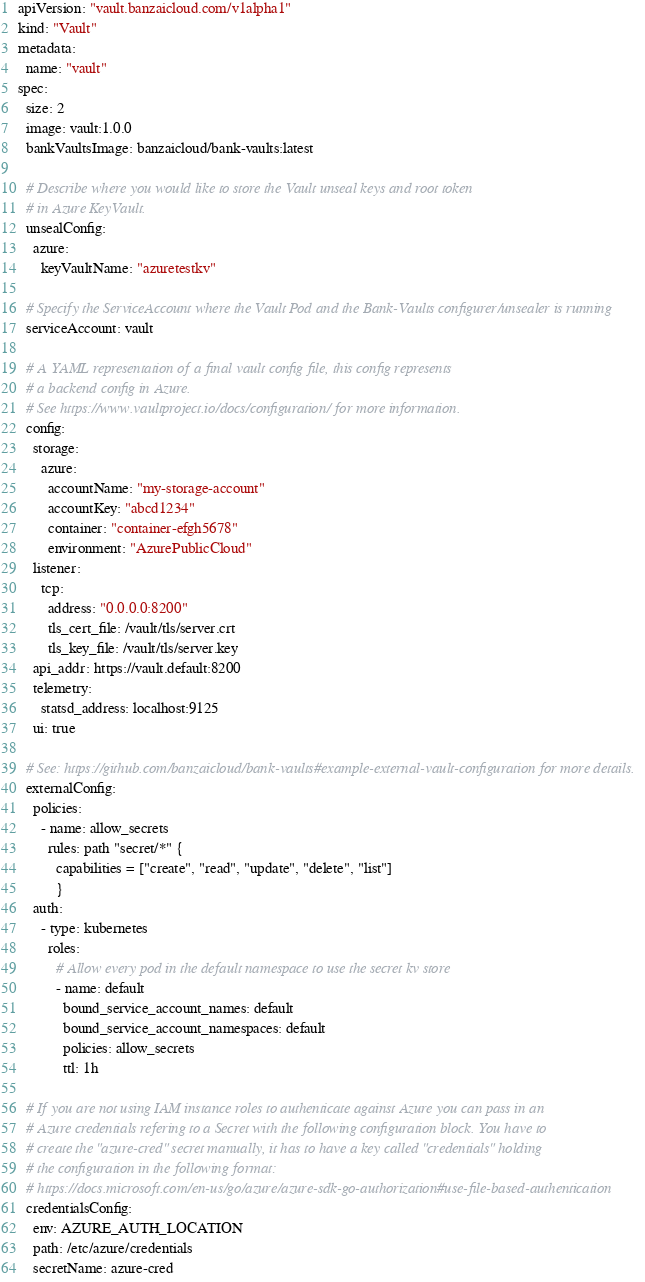<code> <loc_0><loc_0><loc_500><loc_500><_YAML_>apiVersion: "vault.banzaicloud.com/v1alpha1"
kind: "Vault"
metadata:
  name: "vault"
spec:
  size: 2
  image: vault:1.0.0
  bankVaultsImage: banzaicloud/bank-vaults:latest

  # Describe where you would like to store the Vault unseal keys and root token
  # in Azure KeyVault.
  unsealConfig:
    azure:
      keyVaultName: "azuretestkv"

  # Specify the ServiceAccount where the Vault Pod and the Bank-Vaults configurer/unsealer is running
  serviceAccount: vault

  # A YAML representation of a final vault config file, this config represents
  # a backend config in Azure.
  # See https://www.vaultproject.io/docs/configuration/ for more information.
  config:
    storage:
      azure:
        accountName: "my-storage-account"
        accountKey: "abcd1234"
        container: "container-efgh5678"
        environment: "AzurePublicCloud"
    listener:
      tcp:
        address: "0.0.0.0:8200"
        tls_cert_file: /vault/tls/server.crt
        tls_key_file: /vault/tls/server.key
    api_addr: https://vault.default:8200
    telemetry:
      statsd_address: localhost:9125
    ui: true

  # See: https://github.com/banzaicloud/bank-vaults#example-external-vault-configuration for more details.
  externalConfig:
    policies:
      - name: allow_secrets
        rules: path "secret/*" {
          capabilities = ["create", "read", "update", "delete", "list"]
          }
    auth:
      - type: kubernetes
        roles:
          # Allow every pod in the default namespace to use the secret kv store
          - name: default
            bound_service_account_names: default
            bound_service_account_namespaces: default
            policies: allow_secrets
            ttl: 1h

  # If you are not using IAM instance roles to authenticate against Azure you can pass in an
  # Azure credentials refering to a Secret with the following configuration block. You have to
  # create the "azure-cred" secret manually, it has to have a key called "credentials" holding
  # the configuration in the following format:
  # https://docs.microsoft.com/en-us/go/azure/azure-sdk-go-authorization#use-file-based-authentication
  credentialsConfig:
    env: AZURE_AUTH_LOCATION
    path: /etc/azure/credentials
    secretName: azure-cred
</code> 